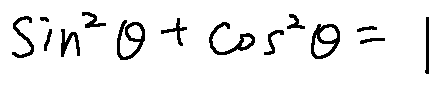Convert formula to latex. <formula><loc_0><loc_0><loc_500><loc_500>\sin ^ { 2 } \theta + \cos ^ { 2 } \theta = 1</formula> 